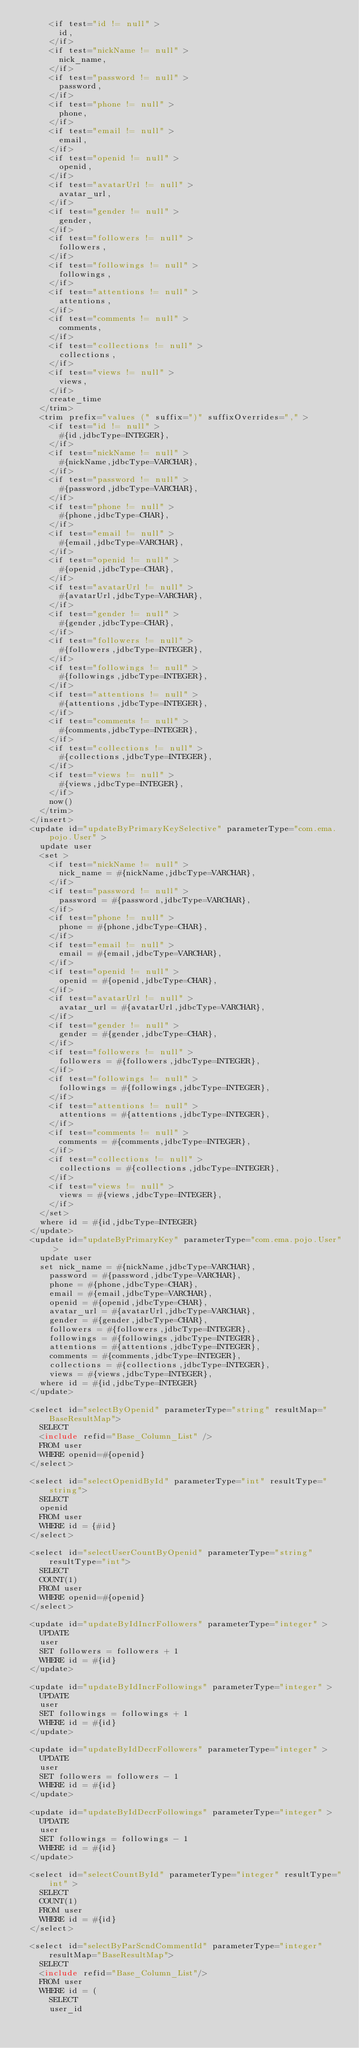<code> <loc_0><loc_0><loc_500><loc_500><_XML_>      <if test="id != null" >
        id,
      </if>
      <if test="nickName != null" >
        nick_name,
      </if>
      <if test="password != null" >
        password,
      </if>
      <if test="phone != null" >
        phone,
      </if>
      <if test="email != null" >
        email,
      </if>
      <if test="openid != null" >
        openid,
      </if>
      <if test="avatarUrl != null" >
        avatar_url,
      </if>
      <if test="gender != null" >
        gender,
      </if>
      <if test="followers != null" >
        followers,
      </if>
      <if test="followings != null" >
        followings,
      </if>
      <if test="attentions != null" >
        attentions,
      </if>
      <if test="comments != null" >
        comments,
      </if>
      <if test="collections != null" >
        collections,
      </if>
      <if test="views != null" >
        views,
      </if>
      create_time
    </trim>
    <trim prefix="values (" suffix=")" suffixOverrides="," >
      <if test="id != null" >
        #{id,jdbcType=INTEGER},
      </if>
      <if test="nickName != null" >
        #{nickName,jdbcType=VARCHAR},
      </if>
      <if test="password != null" >
        #{password,jdbcType=VARCHAR},
      </if>
      <if test="phone != null" >
        #{phone,jdbcType=CHAR},
      </if>
      <if test="email != null" >
        #{email,jdbcType=VARCHAR},
      </if>
      <if test="openid != null" >
        #{openid,jdbcType=CHAR},
      </if>
      <if test="avatarUrl != null" >
        #{avatarUrl,jdbcType=VARCHAR},
      </if>
      <if test="gender != null" >
        #{gender,jdbcType=CHAR},
      </if>
      <if test="followers != null" >
        #{followers,jdbcType=INTEGER},
      </if>
      <if test="followings != null" >
        #{followings,jdbcType=INTEGER},
      </if>
      <if test="attentions != null" >
        #{attentions,jdbcType=INTEGER},
      </if>
      <if test="comments != null" >
        #{comments,jdbcType=INTEGER},
      </if>
      <if test="collections != null" >
        #{collections,jdbcType=INTEGER},
      </if>
      <if test="views != null" >
        #{views,jdbcType=INTEGER},
      </if>
      now()
    </trim>
  </insert>
  <update id="updateByPrimaryKeySelective" parameterType="com.ema.pojo.User" >
    update user
    <set >
      <if test="nickName != null" >
        nick_name = #{nickName,jdbcType=VARCHAR},
      </if>
      <if test="password != null" >
        password = #{password,jdbcType=VARCHAR},
      </if>
      <if test="phone != null" >
        phone = #{phone,jdbcType=CHAR},
      </if>
      <if test="email != null" >
        email = #{email,jdbcType=VARCHAR},
      </if>
      <if test="openid != null" >
        openid = #{openid,jdbcType=CHAR},
      </if>
      <if test="avatarUrl != null" >
        avatar_url = #{avatarUrl,jdbcType=VARCHAR},
      </if>
      <if test="gender != null" >
        gender = #{gender,jdbcType=CHAR},
      </if>
      <if test="followers != null" >
        followers = #{followers,jdbcType=INTEGER},
      </if>
      <if test="followings != null" >
        followings = #{followings,jdbcType=INTEGER},
      </if>
      <if test="attentions != null" >
        attentions = #{attentions,jdbcType=INTEGER},
      </if>
      <if test="comments != null" >
        comments = #{comments,jdbcType=INTEGER},
      </if>
      <if test="collections != null" >
        collections = #{collections,jdbcType=INTEGER},
      </if>
      <if test="views != null" >
        views = #{views,jdbcType=INTEGER},
      </if>
    </set>
    where id = #{id,jdbcType=INTEGER}
  </update>
  <update id="updateByPrimaryKey" parameterType="com.ema.pojo.User" >
    update user
    set nick_name = #{nickName,jdbcType=VARCHAR},
      password = #{password,jdbcType=VARCHAR},
      phone = #{phone,jdbcType=CHAR},
      email = #{email,jdbcType=VARCHAR},
      openid = #{openid,jdbcType=CHAR},
      avatar_url = #{avatarUrl,jdbcType=VARCHAR},
      gender = #{gender,jdbcType=CHAR},
      followers = #{followers,jdbcType=INTEGER},
      followings = #{followings,jdbcType=INTEGER},
      attentions = #{attentions,jdbcType=INTEGER},
      comments = #{comments,jdbcType=INTEGER},
      collections = #{collections,jdbcType=INTEGER},
      views = #{views,jdbcType=INTEGER},
    where id = #{id,jdbcType=INTEGER}
  </update>

  <select id="selectByOpenid" parameterType="string" resultMap="BaseResultMap">
    SELECT
    <include refid="Base_Column_List" />
    FROM user
    WHERE openid=#{openid}
  </select>

  <select id="selectOpenidById" parameterType="int" resultType="string">
    SELECT
    openid
    FROM user
    WHERE id = {#id}
  </select>

  <select id="selectUserCountByOpenid" parameterType="string" resultType="int">
    SELECT
    COUNT(1)
    FROM user
    WHERE openid=#{openid}
  </select>

  <update id="updateByIdIncrFollowers" parameterType="integer" >
    UPDATE
    user
    SET followers = followers + 1
    WHERE id = #{id}
  </update>

  <update id="updateByIdIncrFollowings" parameterType="integer" >
    UPDATE
    user
    SET followings = followings + 1
    WHERE id = #{id}
  </update>

  <update id="updateByIdDecrFollowers" parameterType="integer" >
    UPDATE
    user
    SET followers = followers - 1
    WHERE id = #{id}
  </update>

  <update id="updateByIdDecrFollowings" parameterType="integer" >
    UPDATE
    user
    SET followings = followings - 1
    WHERE id = #{id}
  </update>

  <select id="selectCountById" parameterType="integer" resultType="int" >
    SELECT
    COUNT(1)
    FROM user
    WHERE id = #{id}
  </select>

  <select id="selectByParScndCommentId" parameterType="integer" resultMap="BaseResultMap">
    SELECT
    <include refid="Base_Column_List"/>
    FROM user
    WHERE id = (
      SELECT
      user_id</code> 